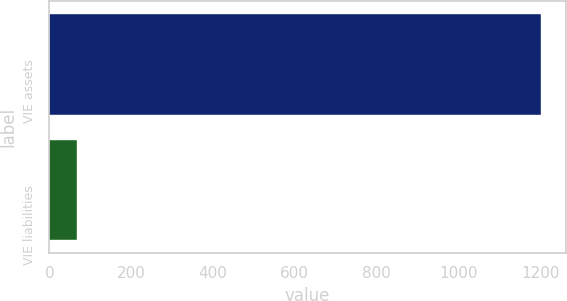<chart> <loc_0><loc_0><loc_500><loc_500><bar_chart><fcel>VIE assets<fcel>VIE liabilities<nl><fcel>1202<fcel>67<nl></chart> 